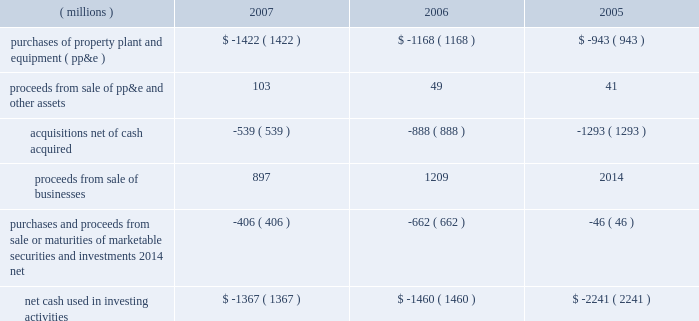Cash flows from operating activities can fluctuate significantly from period to period , as pension funding decisions , tax timing differences and other items can significantly impact cash flows .
In both 2007 and 2006 , the company made discretionary contributions of $ 200 million to its u.s .
Qualified pension plan , and in 2005 made discretionary contributions totaling $ 500 million .
In 2007 , cash flows provided by operating activities increased $ 436 million , including an increase in net income of $ 245 million .
Since the gain from sale of businesses is included in and increases net income , the pre-tax gain from the sale of the businesses must be subtracted , as shown above , to properly reflect operating cash flows .
The cash proceeds from the sale of the pharmaceuticals business are shown as part of cash from investing activities ; however , when the related taxes are paid they are required to be shown as part of cash provided by operating activities .
Thus , operating cash flows for 2007 were penalized due to cash income tax payments of approximately $ 630 million in 2007 that related to the sale of the global branded pharmaceuticals business .
Non-pharmaceutical related cash income tax payments were approximately $ 475 million lower than 2006 due to normal timing differences in tax payments , which benefited cash flows .
Accounts receivable and inventory increases reduced cash flows in 2007 , but decreased cash flow less than in 2006 , resulting in a year-on-year benefit to cash flows of $ 323 million .
The category 201cother-net 201d in the preceding table reflects changes in other asset and liability accounts , including the impact of cash payments made in connection with 3m 2019s restructuring actions ( note 4 ) .
In 2006 , cash flows provided by operating activities decreased $ 365 million .
This decrease was due in large part to an increase of approximately $ 600 million in tax payments in 2006 compared with 2005 .
The higher tax payments in 2006 primarily related to the company 2019s repatriation of $ 1.7 billion of foreign earnings in the united states pursuant to the provisions of the american jobs creation act of 2004 .
The category 201cother-net 201d in the preceding table reflects changes in other asset and liability accounts , including outstanding liabilities at december 31 , 2006 , related to 3m 2019s restructuring actions ( note 4 ) .
Cash flows from investing activities : years ended december 31 .
Investments in property , plant and equipment enable growth in diverse markets , helping to meet product demand and increasing manufacturing efficiency .
In 2007 , numerous plants were opened or expanded internationally .
This included two facilities in korea ( respirator manufacturing facility and optical plant ) , an optical plant in poland , industrial adhesives/tapes facilities in both brazil and the philippines , a plant in russia ( corrosion protection , industrial adhesive and tapes , and respirators ) , a plant in china ( optical systems , industrial adhesives and tapes , and personal care ) , an expansion in canada ( construction and home improvement business ) , in addition to investments in india , mexico and other countries .
In addition , 3m expanded manufacturing capabilities in the u.s. , including investments in industrial adhesives/tapes and optical .
3m also exited several high-cost underutilized manufacturing facilities and streamlined several supply chains by relocating equipment from one facility to another .
The streamlining work has primarily occurred inside the u.s .
And is in addition to the streamlining achieved through plant construction .
As a result of this increased activity , capital expenditures were $ 1.422 billion in 2007 , an increase of $ 254 million when compared to 2006 .
The company expects capital expenditures to total approximately $ 1.3 billion to $ 1.4 billion in 2008 .
Refer to the preceding 201ccapital spending/net property , plant and equipment 201d section for more detail .
Refer to note 2 for information on 2007 , 2006 and 2005 acquisitions .
Note 2 also provides information on the proceeds from the sale of businesses .
The company is actively considering additional acquisitions , investments and strategic alliances , and from time to time may also divest certain businesses .
Purchases of marketable securities and investments and proceeds from sale ( or maturities ) of marketable securities and investments are primarily attributable to asset-backed securities , agency securities , corporate medium-term note securities , auction rate securities and other securities , which are classified as available-for-sale .
Refer to note 9 for more details about 3m 2019s diversified marketable securities portfolio , which totaled $ 1.059 billion as of december 31 , 2007 .
Purchases of marketable securities , net of sales and maturities , totaled $ 429 million for 2007 and $ 637 million for 2006 .
Purchases of investments in 2005 include the purchase of 19% ( 19 % ) of ti&m beteiligungsgesellschaft mbh for .
In 2006 what was the ratio of the increase in tax payments in 2005 and 2006 to the decrease in cash? 
Rationale: in 2006 the decrease in cash flows for every $ 1 it was due in part to an increase in tax payments by $ 1.64
Computations: (600 / 365)
Answer: 1.64384. Cash flows from operating activities can fluctuate significantly from period to period , as pension funding decisions , tax timing differences and other items can significantly impact cash flows .
In both 2007 and 2006 , the company made discretionary contributions of $ 200 million to its u.s .
Qualified pension plan , and in 2005 made discretionary contributions totaling $ 500 million .
In 2007 , cash flows provided by operating activities increased $ 436 million , including an increase in net income of $ 245 million .
Since the gain from sale of businesses is included in and increases net income , the pre-tax gain from the sale of the businesses must be subtracted , as shown above , to properly reflect operating cash flows .
The cash proceeds from the sale of the pharmaceuticals business are shown as part of cash from investing activities ; however , when the related taxes are paid they are required to be shown as part of cash provided by operating activities .
Thus , operating cash flows for 2007 were penalized due to cash income tax payments of approximately $ 630 million in 2007 that related to the sale of the global branded pharmaceuticals business .
Non-pharmaceutical related cash income tax payments were approximately $ 475 million lower than 2006 due to normal timing differences in tax payments , which benefited cash flows .
Accounts receivable and inventory increases reduced cash flows in 2007 , but decreased cash flow less than in 2006 , resulting in a year-on-year benefit to cash flows of $ 323 million .
The category 201cother-net 201d in the preceding table reflects changes in other asset and liability accounts , including the impact of cash payments made in connection with 3m 2019s restructuring actions ( note 4 ) .
In 2006 , cash flows provided by operating activities decreased $ 365 million .
This decrease was due in large part to an increase of approximately $ 600 million in tax payments in 2006 compared with 2005 .
The higher tax payments in 2006 primarily related to the company 2019s repatriation of $ 1.7 billion of foreign earnings in the united states pursuant to the provisions of the american jobs creation act of 2004 .
The category 201cother-net 201d in the preceding table reflects changes in other asset and liability accounts , including outstanding liabilities at december 31 , 2006 , related to 3m 2019s restructuring actions ( note 4 ) .
Cash flows from investing activities : years ended december 31 .
Investments in property , plant and equipment enable growth in diverse markets , helping to meet product demand and increasing manufacturing efficiency .
In 2007 , numerous plants were opened or expanded internationally .
This included two facilities in korea ( respirator manufacturing facility and optical plant ) , an optical plant in poland , industrial adhesives/tapes facilities in both brazil and the philippines , a plant in russia ( corrosion protection , industrial adhesive and tapes , and respirators ) , a plant in china ( optical systems , industrial adhesives and tapes , and personal care ) , an expansion in canada ( construction and home improvement business ) , in addition to investments in india , mexico and other countries .
In addition , 3m expanded manufacturing capabilities in the u.s. , including investments in industrial adhesives/tapes and optical .
3m also exited several high-cost underutilized manufacturing facilities and streamlined several supply chains by relocating equipment from one facility to another .
The streamlining work has primarily occurred inside the u.s .
And is in addition to the streamlining achieved through plant construction .
As a result of this increased activity , capital expenditures were $ 1.422 billion in 2007 , an increase of $ 254 million when compared to 2006 .
The company expects capital expenditures to total approximately $ 1.3 billion to $ 1.4 billion in 2008 .
Refer to the preceding 201ccapital spending/net property , plant and equipment 201d section for more detail .
Refer to note 2 for information on 2007 , 2006 and 2005 acquisitions .
Note 2 also provides information on the proceeds from the sale of businesses .
The company is actively considering additional acquisitions , investments and strategic alliances , and from time to time may also divest certain businesses .
Purchases of marketable securities and investments and proceeds from sale ( or maturities ) of marketable securities and investments are primarily attributable to asset-backed securities , agency securities , corporate medium-term note securities , auction rate securities and other securities , which are classified as available-for-sale .
Refer to note 9 for more details about 3m 2019s diversified marketable securities portfolio , which totaled $ 1.059 billion as of december 31 , 2007 .
Purchases of marketable securities , net of sales and maturities , totaled $ 429 million for 2007 and $ 637 million for 2006 .
Purchases of investments in 2005 include the purchase of 19% ( 19 % ) of ti&m beteiligungsgesellschaft mbh for .
What was the percentage change in the net cash used in investing activities from 2006 to 2007? 
Computations: ((-1367 - -1460) / -1460)
Answer: -0.0637. 